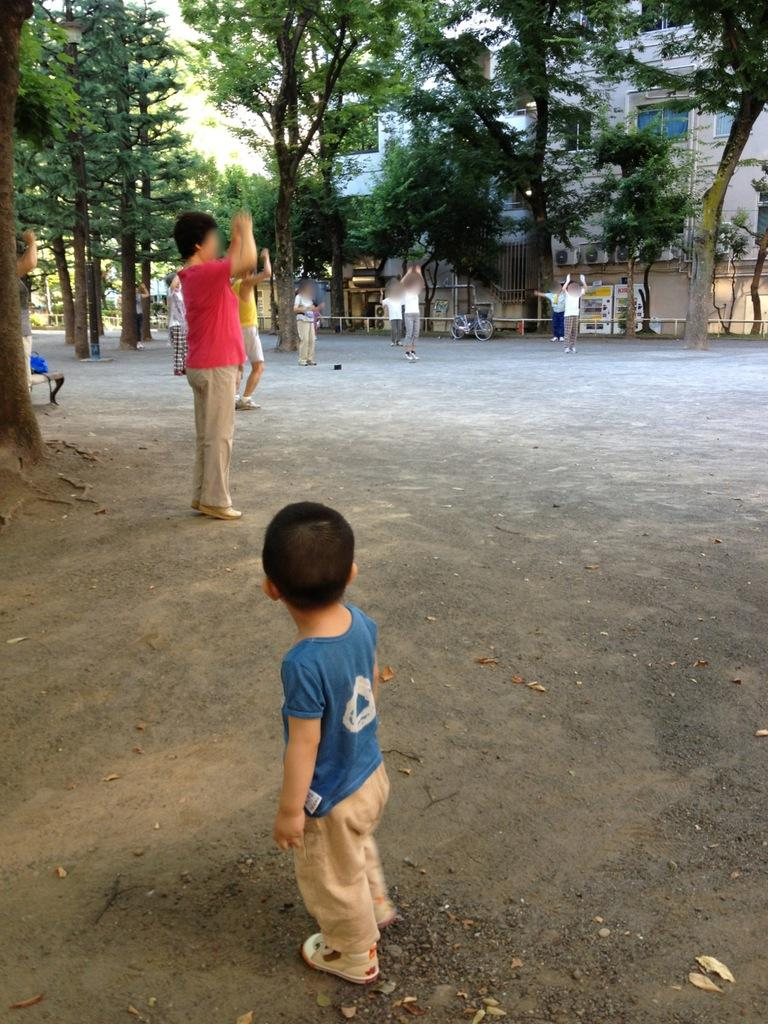What is the main subject of the image? There is a kid standing in the center of the image. What can be seen in the background of the image? The sky, trees, at least one building, and people are visible in the background of the image. Are there any other objects in the background of the image? Yes, there are other objects in the background of the image. What type of train can be seen in the image? There is no train present in the image. What action is the kid attempting to perform in the image? The provided facts do not mention any specific action the kid is attempting to perform. 